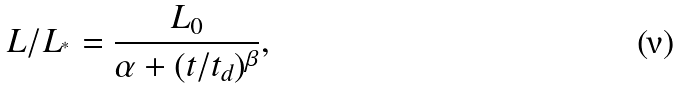<formula> <loc_0><loc_0><loc_500><loc_500>L / L _ { ^ { * } } = \frac { L _ { 0 } } { \alpha + ( t / t _ { d } ) ^ { \beta } } ,</formula> 